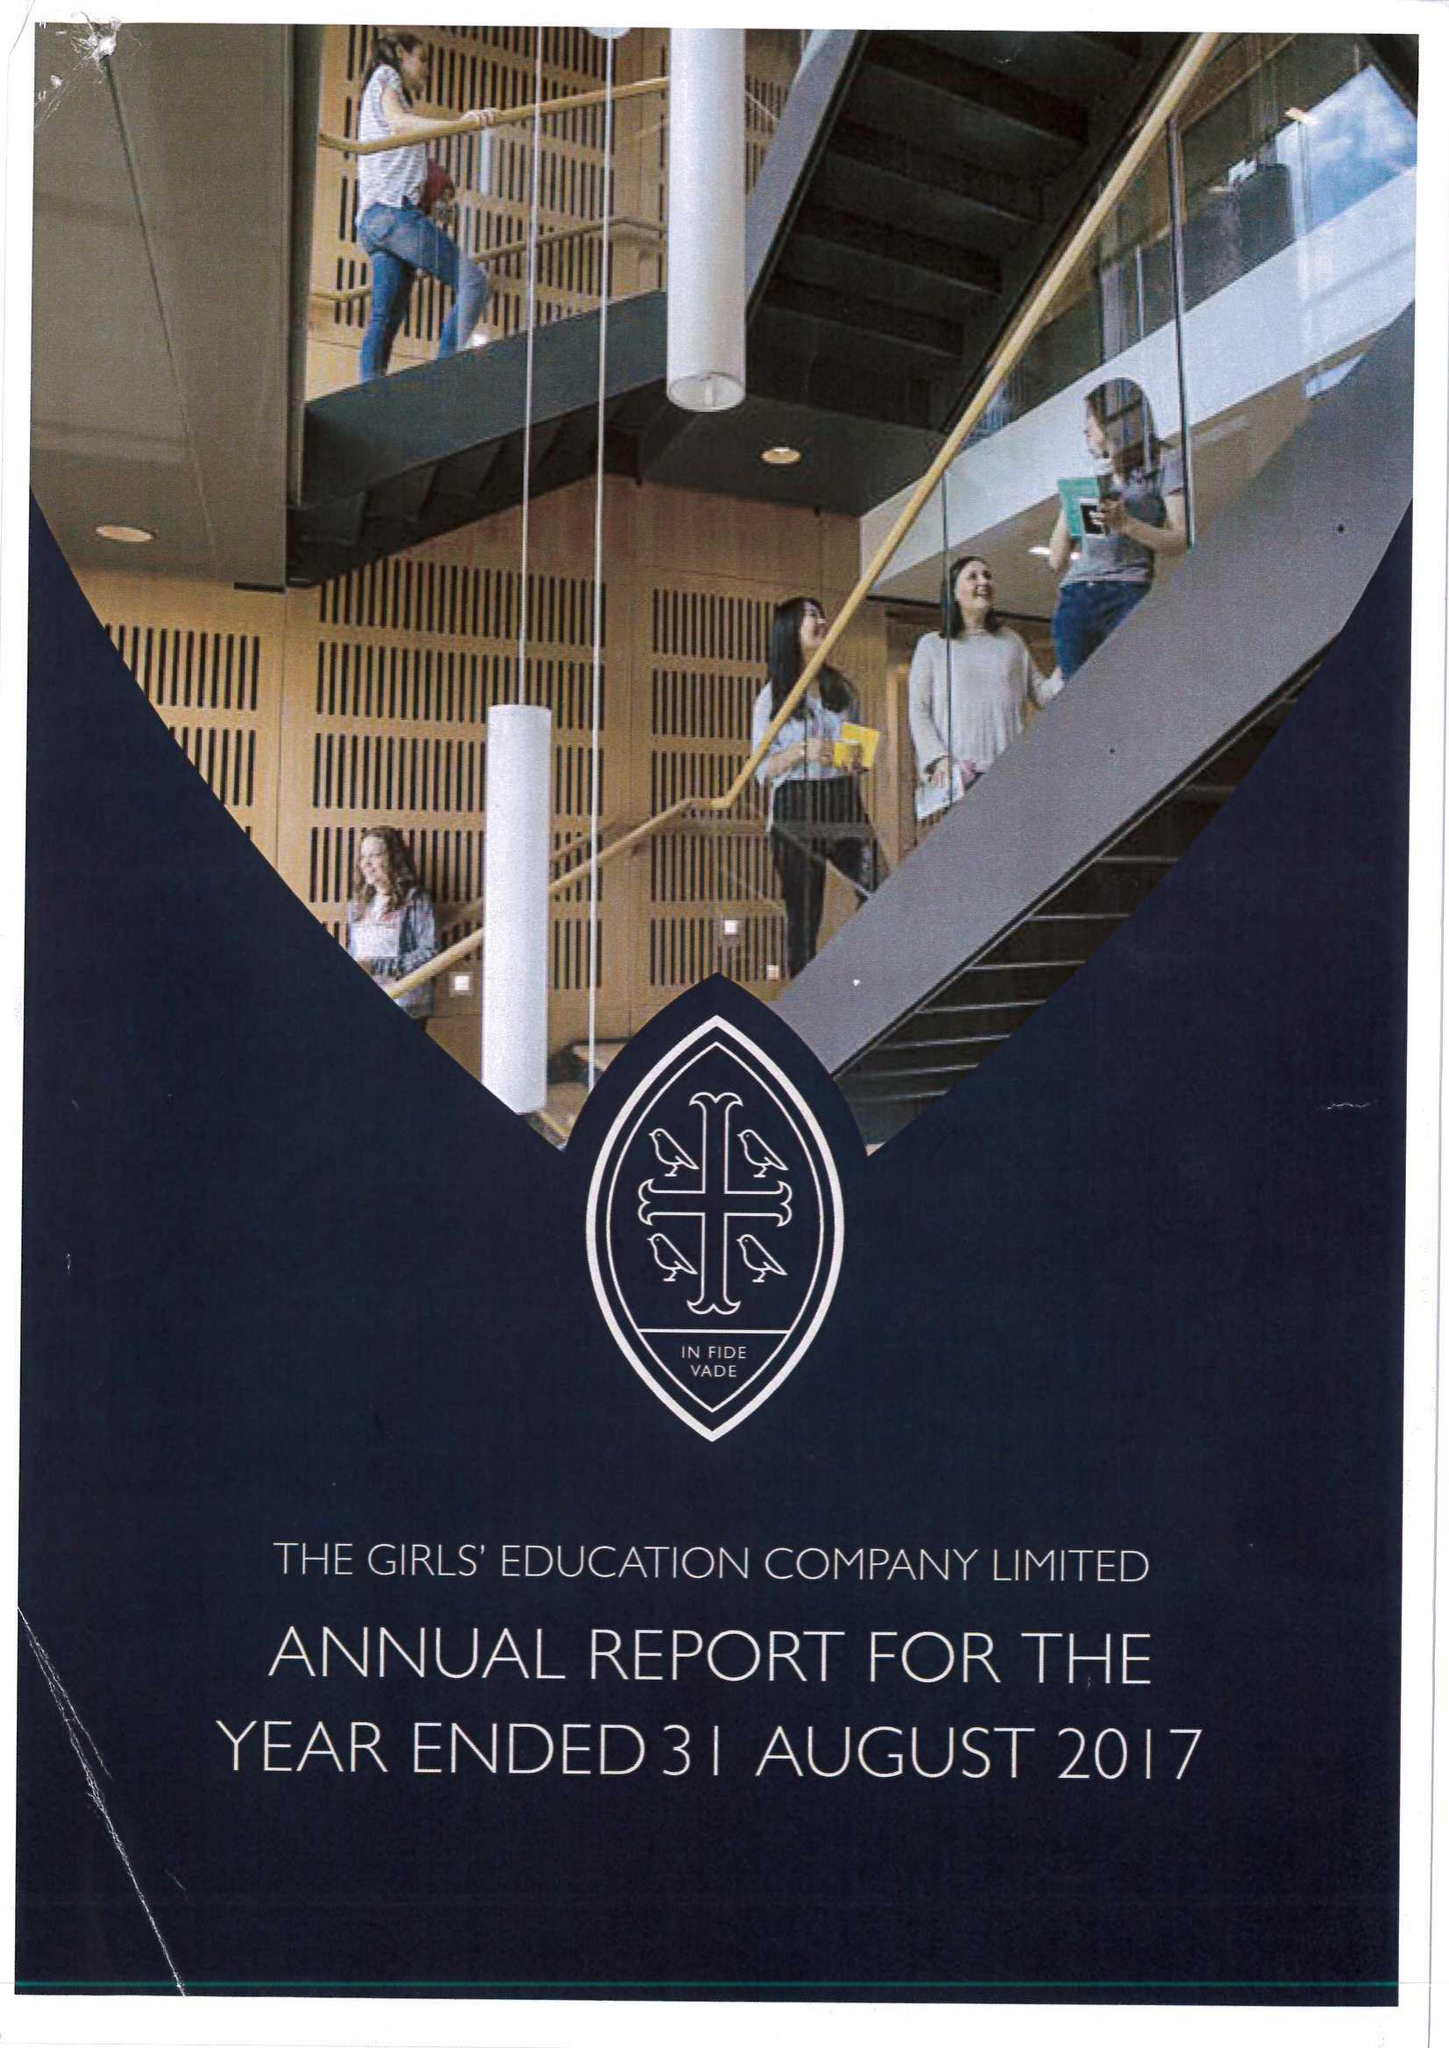What is the value for the report_date?
Answer the question using a single word or phrase. 2017-08-31 